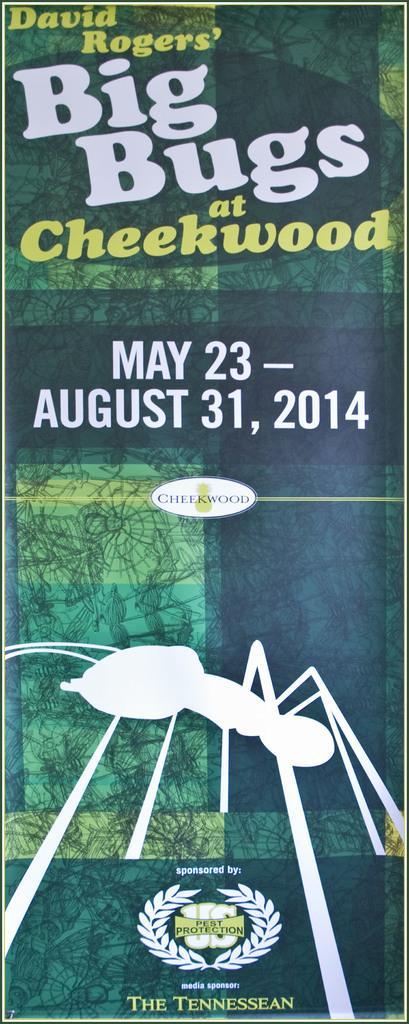How would you summarize this image in a sentence or two? This image consists of a poster in green color on which there is a text along with the date. And there is a picture of an ant. 